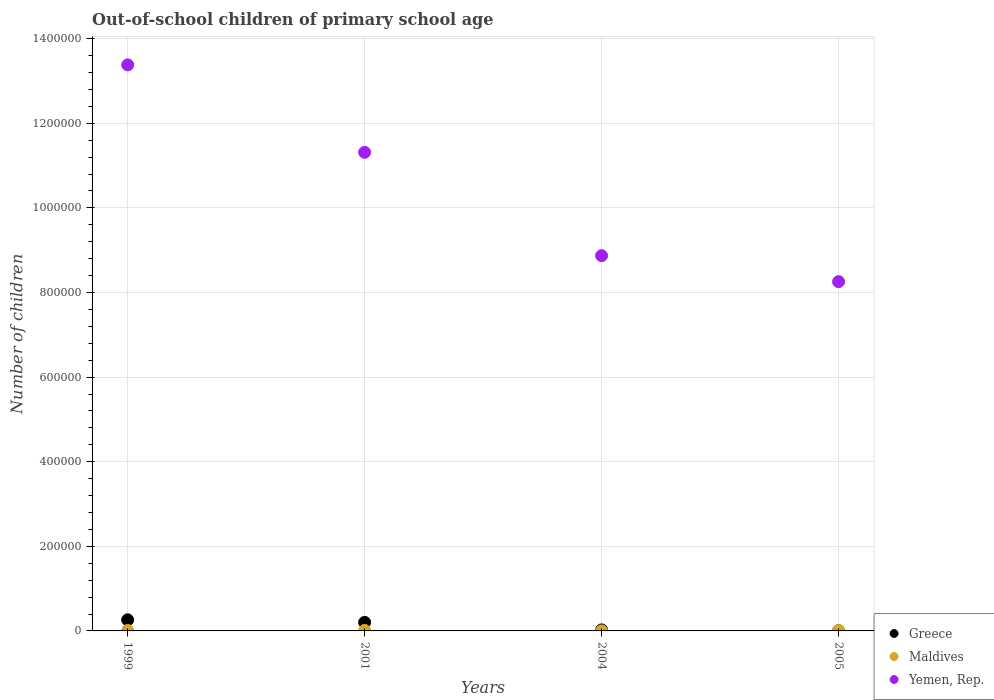Is the number of dotlines equal to the number of legend labels?
Keep it short and to the point. Yes. What is the number of out-of-school children in Yemen, Rep. in 1999?
Provide a succinct answer. 1.34e+06. Across all years, what is the maximum number of out-of-school children in Greece?
Make the answer very short. 2.62e+04. Across all years, what is the minimum number of out-of-school children in Maldives?
Your answer should be compact. 90. In which year was the number of out-of-school children in Maldives maximum?
Give a very brief answer. 2001. What is the total number of out-of-school children in Maldives in the graph?
Keep it short and to the point. 3380. What is the difference between the number of out-of-school children in Maldives in 2001 and that in 2004?
Ensure brevity in your answer.  1115. What is the difference between the number of out-of-school children in Maldives in 2004 and the number of out-of-school children in Yemen, Rep. in 2001?
Your answer should be very brief. -1.13e+06. What is the average number of out-of-school children in Maldives per year?
Give a very brief answer. 845. In the year 2001, what is the difference between the number of out-of-school children in Yemen, Rep. and number of out-of-school children in Greece?
Provide a succinct answer. 1.11e+06. What is the ratio of the number of out-of-school children in Yemen, Rep. in 2001 to that in 2004?
Your response must be concise. 1.28. Is the number of out-of-school children in Maldives in 1999 less than that in 2005?
Offer a terse response. No. Is the difference between the number of out-of-school children in Yemen, Rep. in 1999 and 2005 greater than the difference between the number of out-of-school children in Greece in 1999 and 2005?
Your answer should be very brief. Yes. What is the difference between the highest and the second highest number of out-of-school children in Maldives?
Provide a succinct answer. 109. What is the difference between the highest and the lowest number of out-of-school children in Maldives?
Your answer should be very brief. 1115. In how many years, is the number of out-of-school children in Yemen, Rep. greater than the average number of out-of-school children in Yemen, Rep. taken over all years?
Your answer should be very brief. 2. Is the sum of the number of out-of-school children in Maldives in 1999 and 2004 greater than the maximum number of out-of-school children in Greece across all years?
Make the answer very short. No. Is it the case that in every year, the sum of the number of out-of-school children in Greece and number of out-of-school children in Maldives  is greater than the number of out-of-school children in Yemen, Rep.?
Your answer should be compact. No. Is the number of out-of-school children in Greece strictly greater than the number of out-of-school children in Yemen, Rep. over the years?
Keep it short and to the point. No. How many dotlines are there?
Offer a terse response. 3. How many years are there in the graph?
Give a very brief answer. 4. Does the graph contain grids?
Offer a terse response. Yes. How many legend labels are there?
Provide a succinct answer. 3. How are the legend labels stacked?
Your answer should be compact. Vertical. What is the title of the graph?
Your response must be concise. Out-of-school children of primary school age. Does "United Kingdom" appear as one of the legend labels in the graph?
Ensure brevity in your answer.  No. What is the label or title of the X-axis?
Provide a short and direct response. Years. What is the label or title of the Y-axis?
Ensure brevity in your answer.  Number of children. What is the Number of children of Greece in 1999?
Ensure brevity in your answer.  2.62e+04. What is the Number of children in Maldives in 1999?
Provide a short and direct response. 1096. What is the Number of children in Yemen, Rep. in 1999?
Your response must be concise. 1.34e+06. What is the Number of children of Greece in 2001?
Offer a terse response. 2.03e+04. What is the Number of children in Maldives in 2001?
Provide a short and direct response. 1205. What is the Number of children in Yemen, Rep. in 2001?
Your response must be concise. 1.13e+06. What is the Number of children of Greece in 2004?
Offer a very short reply. 2419. What is the Number of children in Yemen, Rep. in 2004?
Keep it short and to the point. 8.87e+05. What is the Number of children of Greece in 2005?
Offer a very short reply. 623. What is the Number of children in Maldives in 2005?
Your answer should be very brief. 989. What is the Number of children in Yemen, Rep. in 2005?
Ensure brevity in your answer.  8.26e+05. Across all years, what is the maximum Number of children in Greece?
Your answer should be very brief. 2.62e+04. Across all years, what is the maximum Number of children in Maldives?
Offer a very short reply. 1205. Across all years, what is the maximum Number of children of Yemen, Rep.?
Provide a short and direct response. 1.34e+06. Across all years, what is the minimum Number of children of Greece?
Your answer should be very brief. 623. Across all years, what is the minimum Number of children in Maldives?
Offer a very short reply. 90. Across all years, what is the minimum Number of children in Yemen, Rep.?
Your response must be concise. 8.26e+05. What is the total Number of children of Greece in the graph?
Your answer should be very brief. 4.95e+04. What is the total Number of children of Maldives in the graph?
Provide a short and direct response. 3380. What is the total Number of children of Yemen, Rep. in the graph?
Keep it short and to the point. 4.18e+06. What is the difference between the Number of children in Greece in 1999 and that in 2001?
Your response must be concise. 5965. What is the difference between the Number of children of Maldives in 1999 and that in 2001?
Your answer should be compact. -109. What is the difference between the Number of children of Yemen, Rep. in 1999 and that in 2001?
Make the answer very short. 2.07e+05. What is the difference between the Number of children of Greece in 1999 and that in 2004?
Ensure brevity in your answer.  2.38e+04. What is the difference between the Number of children in Maldives in 1999 and that in 2004?
Your answer should be compact. 1006. What is the difference between the Number of children in Yemen, Rep. in 1999 and that in 2004?
Your answer should be very brief. 4.51e+05. What is the difference between the Number of children of Greece in 1999 and that in 2005?
Offer a terse response. 2.56e+04. What is the difference between the Number of children of Maldives in 1999 and that in 2005?
Give a very brief answer. 107. What is the difference between the Number of children of Yemen, Rep. in 1999 and that in 2005?
Your answer should be very brief. 5.12e+05. What is the difference between the Number of children of Greece in 2001 and that in 2004?
Provide a short and direct response. 1.78e+04. What is the difference between the Number of children of Maldives in 2001 and that in 2004?
Make the answer very short. 1115. What is the difference between the Number of children in Yemen, Rep. in 2001 and that in 2004?
Keep it short and to the point. 2.44e+05. What is the difference between the Number of children in Greece in 2001 and that in 2005?
Offer a terse response. 1.96e+04. What is the difference between the Number of children in Maldives in 2001 and that in 2005?
Your answer should be very brief. 216. What is the difference between the Number of children of Yemen, Rep. in 2001 and that in 2005?
Ensure brevity in your answer.  3.06e+05. What is the difference between the Number of children of Greece in 2004 and that in 2005?
Provide a short and direct response. 1796. What is the difference between the Number of children of Maldives in 2004 and that in 2005?
Provide a succinct answer. -899. What is the difference between the Number of children of Yemen, Rep. in 2004 and that in 2005?
Keep it short and to the point. 6.14e+04. What is the difference between the Number of children of Greece in 1999 and the Number of children of Maldives in 2001?
Give a very brief answer. 2.50e+04. What is the difference between the Number of children in Greece in 1999 and the Number of children in Yemen, Rep. in 2001?
Give a very brief answer. -1.11e+06. What is the difference between the Number of children of Maldives in 1999 and the Number of children of Yemen, Rep. in 2001?
Your answer should be very brief. -1.13e+06. What is the difference between the Number of children in Greece in 1999 and the Number of children in Maldives in 2004?
Your response must be concise. 2.61e+04. What is the difference between the Number of children in Greece in 1999 and the Number of children in Yemen, Rep. in 2004?
Your answer should be very brief. -8.61e+05. What is the difference between the Number of children in Maldives in 1999 and the Number of children in Yemen, Rep. in 2004?
Your answer should be very brief. -8.86e+05. What is the difference between the Number of children in Greece in 1999 and the Number of children in Maldives in 2005?
Ensure brevity in your answer.  2.52e+04. What is the difference between the Number of children of Greece in 1999 and the Number of children of Yemen, Rep. in 2005?
Ensure brevity in your answer.  -7.99e+05. What is the difference between the Number of children in Maldives in 1999 and the Number of children in Yemen, Rep. in 2005?
Make the answer very short. -8.25e+05. What is the difference between the Number of children in Greece in 2001 and the Number of children in Maldives in 2004?
Provide a short and direct response. 2.02e+04. What is the difference between the Number of children of Greece in 2001 and the Number of children of Yemen, Rep. in 2004?
Your response must be concise. -8.67e+05. What is the difference between the Number of children in Maldives in 2001 and the Number of children in Yemen, Rep. in 2004?
Provide a short and direct response. -8.86e+05. What is the difference between the Number of children in Greece in 2001 and the Number of children in Maldives in 2005?
Your answer should be very brief. 1.93e+04. What is the difference between the Number of children of Greece in 2001 and the Number of children of Yemen, Rep. in 2005?
Give a very brief answer. -8.05e+05. What is the difference between the Number of children of Maldives in 2001 and the Number of children of Yemen, Rep. in 2005?
Keep it short and to the point. -8.24e+05. What is the difference between the Number of children of Greece in 2004 and the Number of children of Maldives in 2005?
Your response must be concise. 1430. What is the difference between the Number of children in Greece in 2004 and the Number of children in Yemen, Rep. in 2005?
Ensure brevity in your answer.  -8.23e+05. What is the difference between the Number of children of Maldives in 2004 and the Number of children of Yemen, Rep. in 2005?
Provide a short and direct response. -8.26e+05. What is the average Number of children in Greece per year?
Make the answer very short. 1.24e+04. What is the average Number of children in Maldives per year?
Your answer should be compact. 845. What is the average Number of children of Yemen, Rep. per year?
Offer a very short reply. 1.05e+06. In the year 1999, what is the difference between the Number of children in Greece and Number of children in Maldives?
Provide a succinct answer. 2.51e+04. In the year 1999, what is the difference between the Number of children of Greece and Number of children of Yemen, Rep.?
Provide a succinct answer. -1.31e+06. In the year 1999, what is the difference between the Number of children in Maldives and Number of children in Yemen, Rep.?
Offer a very short reply. -1.34e+06. In the year 2001, what is the difference between the Number of children of Greece and Number of children of Maldives?
Offer a terse response. 1.91e+04. In the year 2001, what is the difference between the Number of children in Greece and Number of children in Yemen, Rep.?
Provide a succinct answer. -1.11e+06. In the year 2001, what is the difference between the Number of children of Maldives and Number of children of Yemen, Rep.?
Give a very brief answer. -1.13e+06. In the year 2004, what is the difference between the Number of children in Greece and Number of children in Maldives?
Your answer should be compact. 2329. In the year 2004, what is the difference between the Number of children in Greece and Number of children in Yemen, Rep.?
Give a very brief answer. -8.85e+05. In the year 2004, what is the difference between the Number of children of Maldives and Number of children of Yemen, Rep.?
Keep it short and to the point. -8.87e+05. In the year 2005, what is the difference between the Number of children in Greece and Number of children in Maldives?
Ensure brevity in your answer.  -366. In the year 2005, what is the difference between the Number of children in Greece and Number of children in Yemen, Rep.?
Your response must be concise. -8.25e+05. In the year 2005, what is the difference between the Number of children in Maldives and Number of children in Yemen, Rep.?
Provide a succinct answer. -8.25e+05. What is the ratio of the Number of children in Greece in 1999 to that in 2001?
Provide a short and direct response. 1.29. What is the ratio of the Number of children of Maldives in 1999 to that in 2001?
Make the answer very short. 0.91. What is the ratio of the Number of children in Yemen, Rep. in 1999 to that in 2001?
Offer a very short reply. 1.18. What is the ratio of the Number of children in Greece in 1999 to that in 2004?
Give a very brief answer. 10.84. What is the ratio of the Number of children of Maldives in 1999 to that in 2004?
Your response must be concise. 12.18. What is the ratio of the Number of children of Yemen, Rep. in 1999 to that in 2004?
Your answer should be very brief. 1.51. What is the ratio of the Number of children in Greece in 1999 to that in 2005?
Keep it short and to the point. 42.11. What is the ratio of the Number of children in Maldives in 1999 to that in 2005?
Your answer should be compact. 1.11. What is the ratio of the Number of children of Yemen, Rep. in 1999 to that in 2005?
Provide a succinct answer. 1.62. What is the ratio of the Number of children in Greece in 2001 to that in 2004?
Give a very brief answer. 8.38. What is the ratio of the Number of children in Maldives in 2001 to that in 2004?
Give a very brief answer. 13.39. What is the ratio of the Number of children of Yemen, Rep. in 2001 to that in 2004?
Your response must be concise. 1.28. What is the ratio of the Number of children of Greece in 2001 to that in 2005?
Make the answer very short. 32.53. What is the ratio of the Number of children of Maldives in 2001 to that in 2005?
Your answer should be compact. 1.22. What is the ratio of the Number of children of Yemen, Rep. in 2001 to that in 2005?
Your answer should be compact. 1.37. What is the ratio of the Number of children in Greece in 2004 to that in 2005?
Keep it short and to the point. 3.88. What is the ratio of the Number of children of Maldives in 2004 to that in 2005?
Make the answer very short. 0.09. What is the ratio of the Number of children of Yemen, Rep. in 2004 to that in 2005?
Offer a very short reply. 1.07. What is the difference between the highest and the second highest Number of children of Greece?
Your answer should be compact. 5965. What is the difference between the highest and the second highest Number of children in Maldives?
Your answer should be compact. 109. What is the difference between the highest and the second highest Number of children in Yemen, Rep.?
Offer a very short reply. 2.07e+05. What is the difference between the highest and the lowest Number of children of Greece?
Your answer should be very brief. 2.56e+04. What is the difference between the highest and the lowest Number of children in Maldives?
Provide a succinct answer. 1115. What is the difference between the highest and the lowest Number of children in Yemen, Rep.?
Provide a succinct answer. 5.12e+05. 